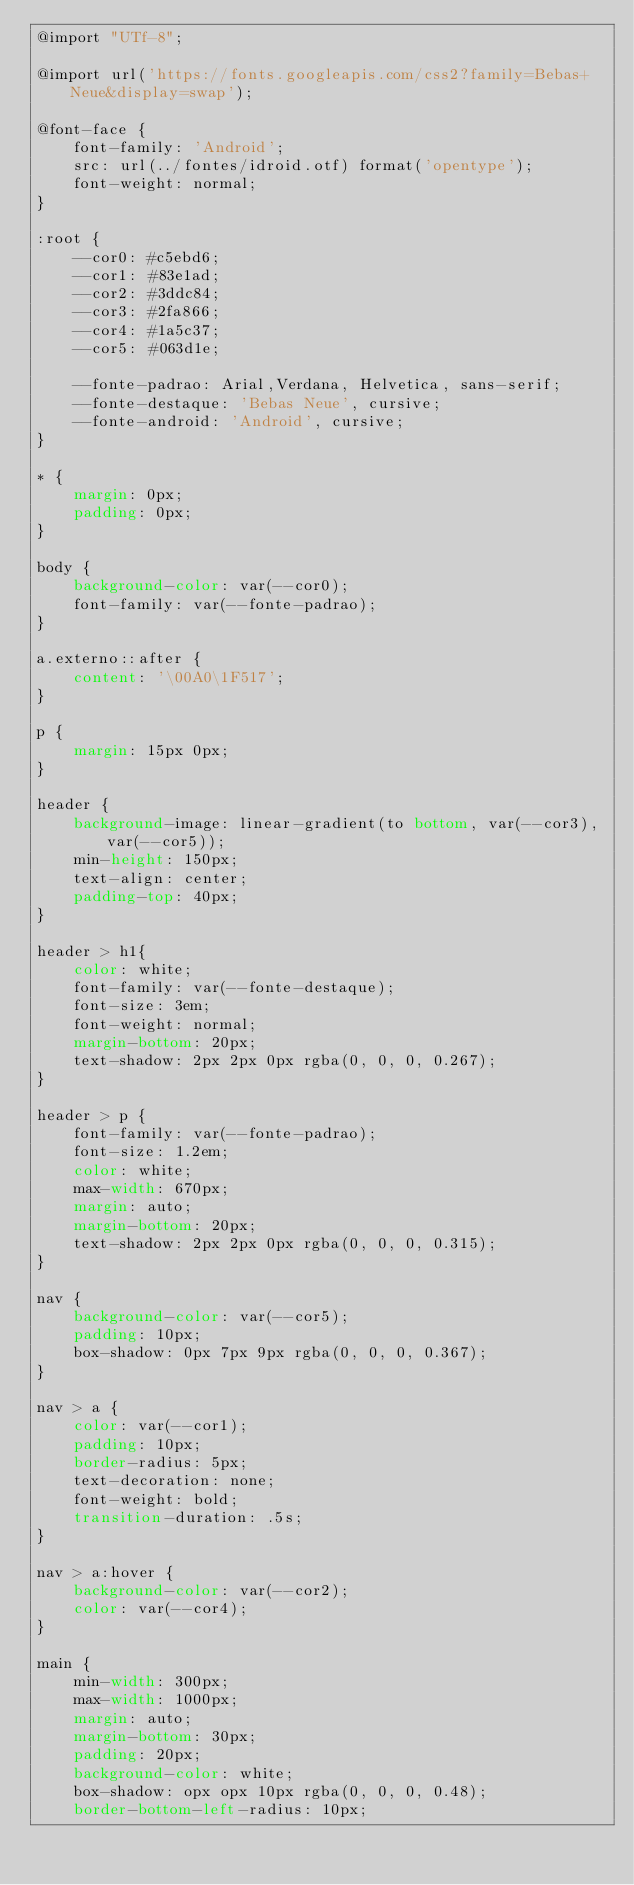Convert code to text. <code><loc_0><loc_0><loc_500><loc_500><_CSS_>@import "UTf-8";

@import url('https://fonts.googleapis.com/css2?family=Bebas+Neue&display=swap');

@font-face {
    font-family: 'Android';
    src: url(../fontes/idroid.otf) format('opentype');
    font-weight: normal;
}

:root {
    --cor0: #c5ebd6;
    --cor1: #83e1ad;
    --cor2: #3ddc84;
    --cor3: #2fa866;
    --cor4: #1a5c37;
    --cor5: #063d1e;

    --fonte-padrao: Arial,Verdana, Helvetica, sans-serif;
    --fonte-destaque: 'Bebas Neue', cursive;
    --fonte-android: 'Android', cursive;
}

* {
    margin: 0px;
    padding: 0px;
}

body {
    background-color: var(--cor0);
    font-family: var(--fonte-padrao);
}

a.externo::after {
    content: '\00A0\1F517';
}

p {
    margin: 15px 0px;
}

header {
    background-image: linear-gradient(to bottom, var(--cor3), var(--cor5));
    min-height: 150px;
    text-align: center;
    padding-top: 40px;
}

header > h1{
    color: white;
    font-family: var(--fonte-destaque);
    font-size: 3em;
    font-weight: normal;
    margin-bottom: 20px;
    text-shadow: 2px 2px 0px rgba(0, 0, 0, 0.267);
}

header > p {
    font-family: var(--fonte-padrao);
    font-size: 1.2em;
    color: white;
    max-width: 670px;
    margin: auto;
    margin-bottom: 20px;
    text-shadow: 2px 2px 0px rgba(0, 0, 0, 0.315);
}

nav {
    background-color: var(--cor5);
    padding: 10px;
    box-shadow: 0px 7px 9px rgba(0, 0, 0, 0.367);
}

nav > a {
    color: var(--cor1);
    padding: 10px;
    border-radius: 5px;
    text-decoration: none;
    font-weight: bold;
    transition-duration: .5s;
}

nav > a:hover {
    background-color: var(--cor2);
    color: var(--cor4);
}

main {
    min-width: 300px;
    max-width: 1000px;
    margin: auto;
    margin-bottom: 30px;
    padding: 20px;
    background-color: white;
    box-shadow: opx opx 10px rgba(0, 0, 0, 0.48);
    border-bottom-left-radius: 10px;</code> 